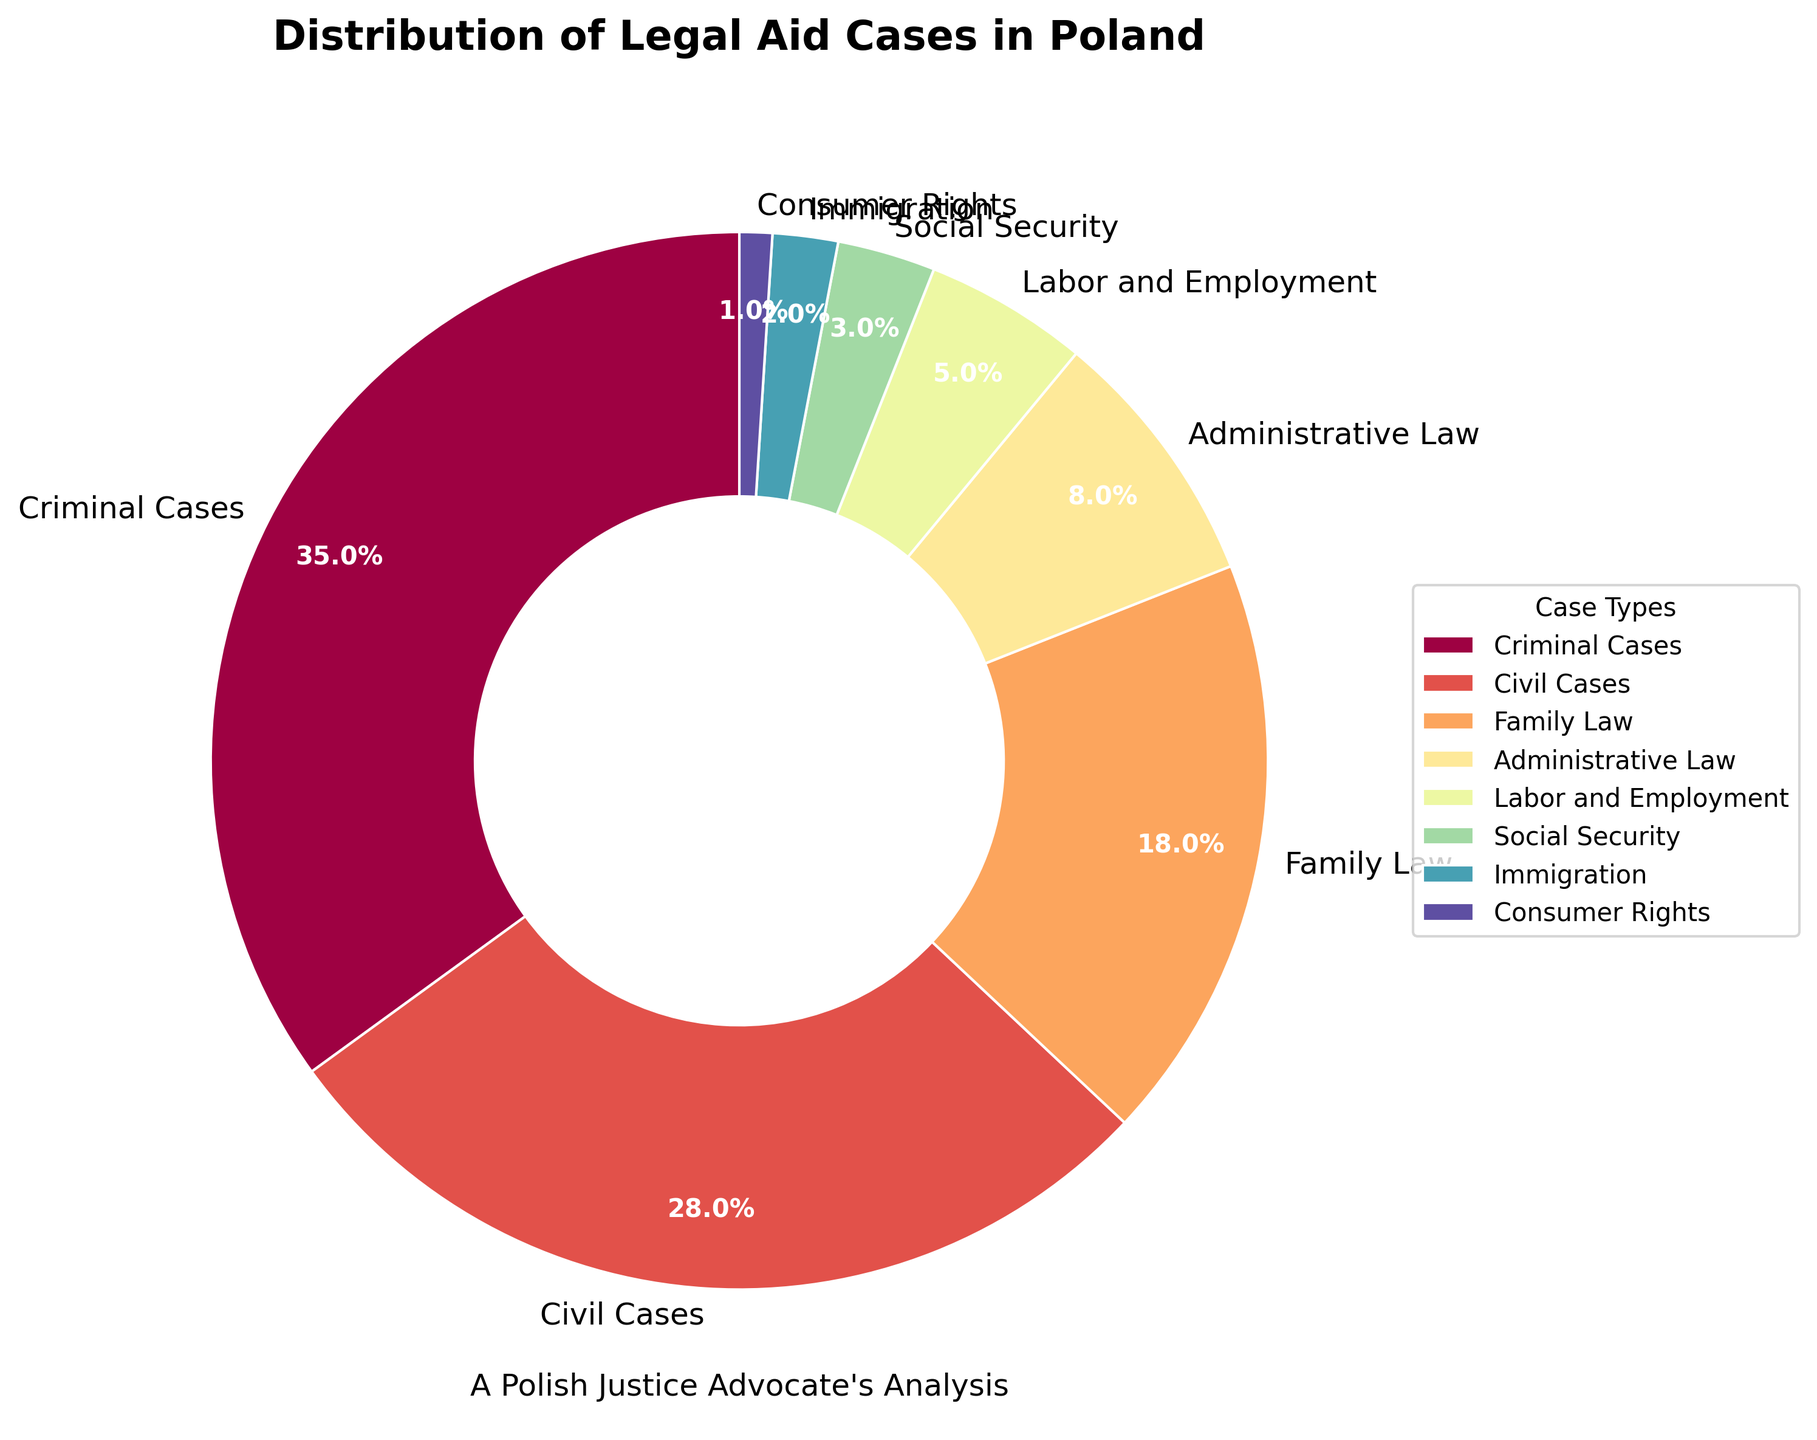What is the percentage of criminal cases in the legal aid distribution? The pie chart shows that the segment labeled "Criminal Cases" has a percentage next to it.
Answer: 35% How much larger is the percentage of civil cases compared to family law cases? The percentage for civil cases is 28%, and for family law cases, it is 18%. Subtracting 18% from 28% gives the difference.
Answer: 10% Which category has the least representation in the distribution of legal aid cases and what is its percentage? The smallest segment in the chart is labeled "Consumer Rights", and the percentage next to it indicates its value.
Answer: 1% Sum the percentages of administrative law and labor and employment cases. Adding the percentages for administrative law (8%) and labor and employment cases (5%) gives 8% + 5%.
Answer: 13% Are social security cases more or less frequent than immigration cases? The pie chart shows that social security cases have a percentage of 3% and immigration cases have a percentage of 2%. Comparing these values shows that social security cases are more frequent.
Answer: More What is the difference in the size of the segments for family law and immigration cases? Family law has 18% and immigration has 2%. Subtracting 2% from 18% gives the difference.
Answer: 16% Which case types together account for more than half of the legal aid cases? Adding the percentages of various segments: Criminal (35%) + Civil (28%) = 63%, which is more than 50%. Verify if adding any smaller segments exceeds 50%, confirming it with Criminal and Civil alone.
Answer: Criminal and Civil What's the second largest segment on the pie chart? Observing the pie chart, the second largest segment after "Criminal Cases" (35%) is labeled "Civil Cases" with 28%.
Answer: Civil Cases Which color represents administrative law? Locate the segment labeled "Administrative Law" on the chart and identify its color.
Answer: Varies (based on color scheme, typically a shade provided by Spectral colormap) How many case types have a percentage below 10? Identify and count all segments in the pie chart with percentages below 10%, specifically noting Administrative Law (8%), Labor and Employment (5%), Social Security (3%), Immigration (2%), and Consumer Rights (1%).
Answer: 5 